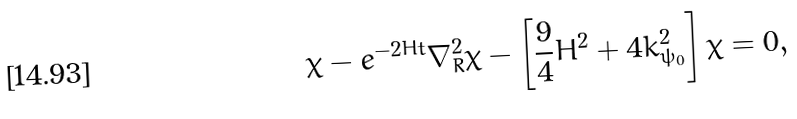<formula> <loc_0><loc_0><loc_500><loc_500>\ddot { \chi } - e ^ { - 2 H t } \nabla ^ { 2 } _ { R } \chi - \left [ \frac { 9 } { 4 } H ^ { 2 } + 4 k ^ { 2 } _ { \psi _ { 0 } } \right ] \chi = 0 ,</formula> 